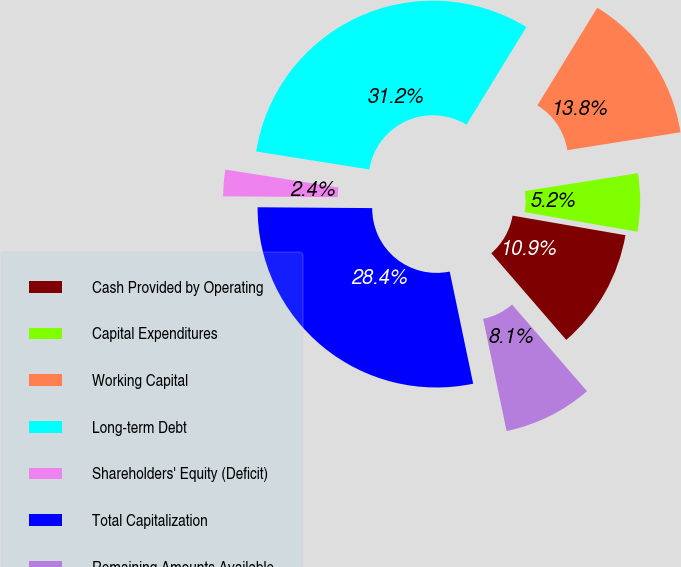Convert chart to OTSL. <chart><loc_0><loc_0><loc_500><loc_500><pie_chart><fcel>Cash Provided by Operating<fcel>Capital Expenditures<fcel>Working Capital<fcel>Long-term Debt<fcel>Shareholders' Equity (Deficit)<fcel>Total Capitalization<fcel>Remaining Amounts Available<nl><fcel>10.91%<fcel>5.23%<fcel>13.75%<fcel>31.24%<fcel>2.39%<fcel>28.4%<fcel>8.07%<nl></chart> 